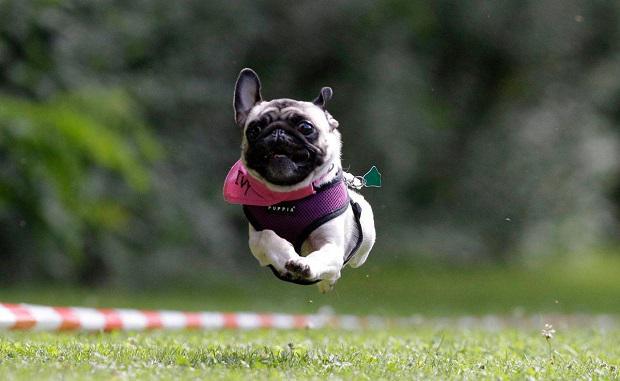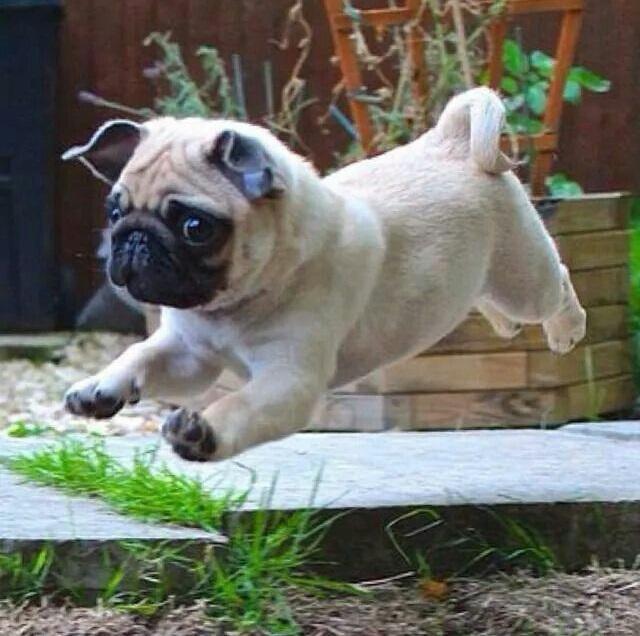The first image is the image on the left, the second image is the image on the right. Assess this claim about the two images: "there is at least one dog in the image pair running and none of it's feet are touching the ground". Correct or not? Answer yes or no. Yes. The first image is the image on the left, the second image is the image on the right. Evaluate the accuracy of this statement regarding the images: "There are at least four pugs in total.". Is it true? Answer yes or no. No. 